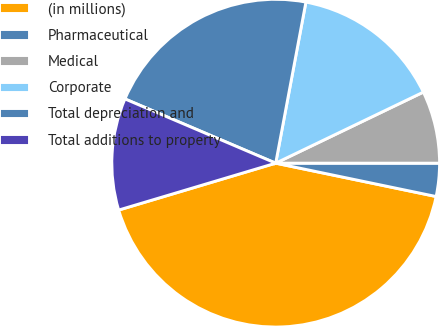Convert chart. <chart><loc_0><loc_0><loc_500><loc_500><pie_chart><fcel>(in millions)<fcel>Pharmaceutical<fcel>Medical<fcel>Corporate<fcel>Total depreciation and<fcel>Total additions to property<nl><fcel>42.12%<fcel>3.26%<fcel>7.14%<fcel>14.91%<fcel>21.54%<fcel>11.03%<nl></chart> 